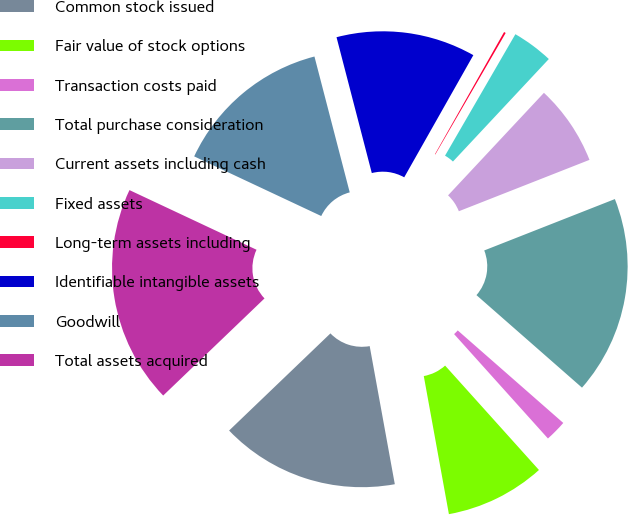<chart> <loc_0><loc_0><loc_500><loc_500><pie_chart><fcel>Common stock issued<fcel>Fair value of stock options<fcel>Transaction costs paid<fcel>Total purchase consideration<fcel>Current assets including cash<fcel>Fixed assets<fcel>Long-term assets including<fcel>Identifiable intangible assets<fcel>Goodwill<fcel>Total assets acquired<nl><fcel>15.7%<fcel>8.79%<fcel>1.89%<fcel>17.42%<fcel>7.07%<fcel>3.61%<fcel>0.16%<fcel>12.24%<fcel>13.97%<fcel>19.15%<nl></chart> 